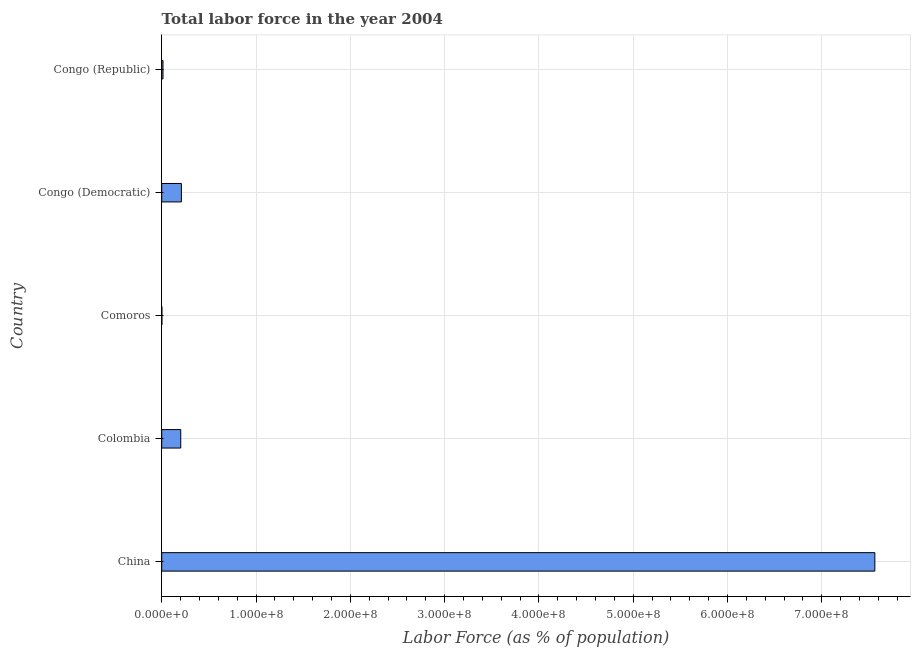Does the graph contain grids?
Make the answer very short. Yes. What is the title of the graph?
Ensure brevity in your answer.  Total labor force in the year 2004. What is the label or title of the X-axis?
Your answer should be compact. Labor Force (as % of population). What is the total labor force in Congo (Republic)?
Give a very brief answer. 1.37e+06. Across all countries, what is the maximum total labor force?
Offer a very short reply. 7.56e+08. Across all countries, what is the minimum total labor force?
Give a very brief answer. 1.93e+05. In which country was the total labor force maximum?
Make the answer very short. China. In which country was the total labor force minimum?
Offer a very short reply. Comoros. What is the sum of the total labor force?
Your response must be concise. 7.99e+08. What is the difference between the total labor force in China and Colombia?
Provide a short and direct response. 7.36e+08. What is the average total labor force per country?
Offer a terse response. 1.60e+08. What is the median total labor force?
Offer a very short reply. 2.02e+07. In how many countries, is the total labor force greater than 380000000 %?
Your answer should be compact. 1. What is the ratio of the total labor force in China to that in Colombia?
Offer a terse response. 37.46. Is the total labor force in Colombia less than that in Comoros?
Provide a short and direct response. No. Is the difference between the total labor force in Colombia and Congo (Democratic) greater than the difference between any two countries?
Your answer should be compact. No. What is the difference between the highest and the second highest total labor force?
Keep it short and to the point. 7.35e+08. Is the sum of the total labor force in China and Colombia greater than the maximum total labor force across all countries?
Offer a terse response. Yes. What is the difference between the highest and the lowest total labor force?
Offer a very short reply. 7.56e+08. In how many countries, is the total labor force greater than the average total labor force taken over all countries?
Your answer should be compact. 1. Are all the bars in the graph horizontal?
Keep it short and to the point. Yes. What is the difference between two consecutive major ticks on the X-axis?
Provide a short and direct response. 1.00e+08. Are the values on the major ticks of X-axis written in scientific E-notation?
Make the answer very short. Yes. What is the Labor Force (as % of population) of China?
Provide a short and direct response. 7.56e+08. What is the Labor Force (as % of population) of Colombia?
Provide a succinct answer. 2.02e+07. What is the Labor Force (as % of population) of Comoros?
Your answer should be very brief. 1.93e+05. What is the Labor Force (as % of population) of Congo (Democratic)?
Your answer should be very brief. 2.09e+07. What is the Labor Force (as % of population) of Congo (Republic)?
Your answer should be compact. 1.37e+06. What is the difference between the Labor Force (as % of population) in China and Colombia?
Keep it short and to the point. 7.36e+08. What is the difference between the Labor Force (as % of population) in China and Comoros?
Your answer should be compact. 7.56e+08. What is the difference between the Labor Force (as % of population) in China and Congo (Democratic)?
Offer a terse response. 7.35e+08. What is the difference between the Labor Force (as % of population) in China and Congo (Republic)?
Your answer should be compact. 7.55e+08. What is the difference between the Labor Force (as % of population) in Colombia and Comoros?
Your answer should be very brief. 2.00e+07. What is the difference between the Labor Force (as % of population) in Colombia and Congo (Democratic)?
Keep it short and to the point. -6.81e+05. What is the difference between the Labor Force (as % of population) in Colombia and Congo (Republic)?
Provide a short and direct response. 1.88e+07. What is the difference between the Labor Force (as % of population) in Comoros and Congo (Democratic)?
Provide a short and direct response. -2.07e+07. What is the difference between the Labor Force (as % of population) in Comoros and Congo (Republic)?
Your response must be concise. -1.18e+06. What is the difference between the Labor Force (as % of population) in Congo (Democratic) and Congo (Republic)?
Your answer should be compact. 1.95e+07. What is the ratio of the Labor Force (as % of population) in China to that in Colombia?
Ensure brevity in your answer.  37.46. What is the ratio of the Labor Force (as % of population) in China to that in Comoros?
Your response must be concise. 3919. What is the ratio of the Labor Force (as % of population) in China to that in Congo (Democratic)?
Your response must be concise. 36.24. What is the ratio of the Labor Force (as % of population) in China to that in Congo (Republic)?
Provide a short and direct response. 550.46. What is the ratio of the Labor Force (as % of population) in Colombia to that in Comoros?
Ensure brevity in your answer.  104.62. What is the ratio of the Labor Force (as % of population) in Colombia to that in Congo (Democratic)?
Provide a short and direct response. 0.97. What is the ratio of the Labor Force (as % of population) in Colombia to that in Congo (Republic)?
Make the answer very short. 14.7. What is the ratio of the Labor Force (as % of population) in Comoros to that in Congo (Democratic)?
Make the answer very short. 0.01. What is the ratio of the Labor Force (as % of population) in Comoros to that in Congo (Republic)?
Your response must be concise. 0.14. What is the ratio of the Labor Force (as % of population) in Congo (Democratic) to that in Congo (Republic)?
Your answer should be very brief. 15.19. 